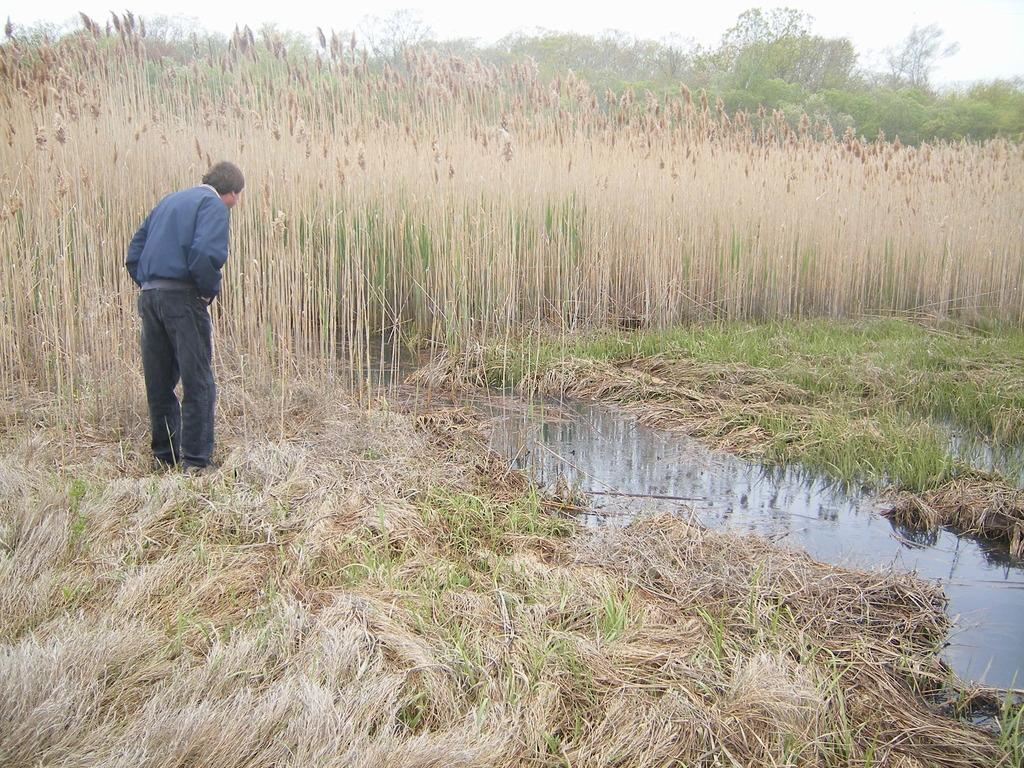What is located on the left side of the image? There is a man on the left side of the image. What is the man wearing? The man is wearing a t-shirt and trousers. What is the man's posture in the image? The man is standing. What can be seen in the middle of the image? There are plants, grass, water, trees, and the sky visible in the middle of the image. What type of apple can be seen falling from the sky in the image? There is no apple falling from the sky in the image. Is there a bag visible in the image? No, there is no bag present in the image. 